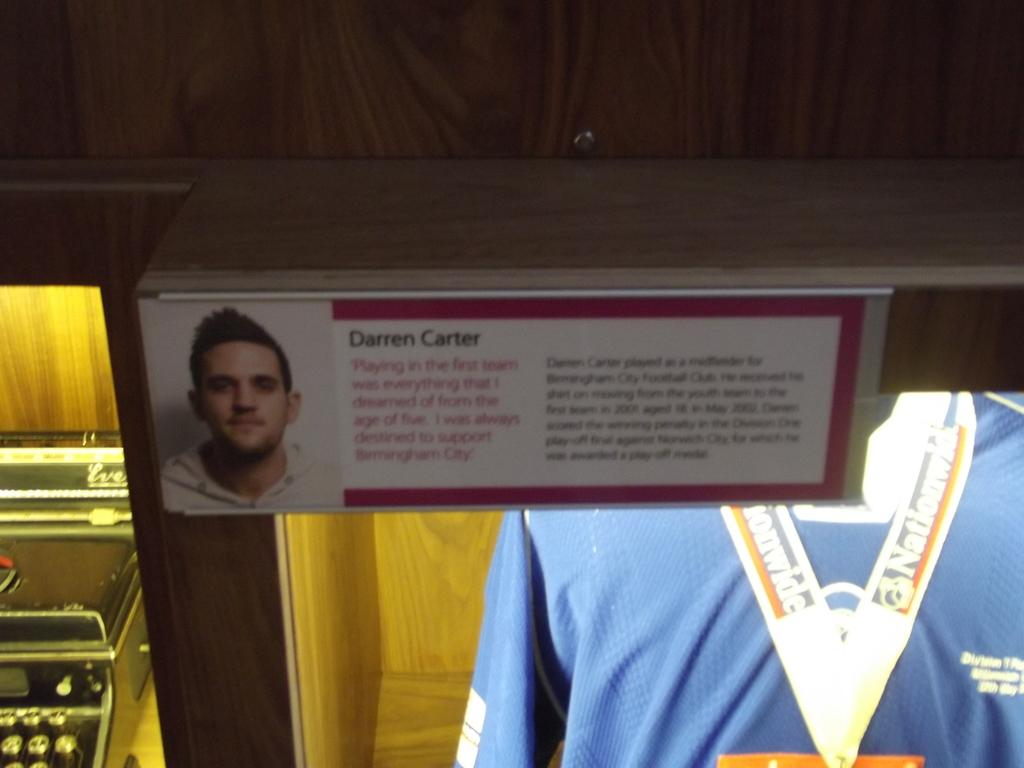<image>
Offer a succinct explanation of the picture presented. A wood case with Darren Carter's jersey in it. 